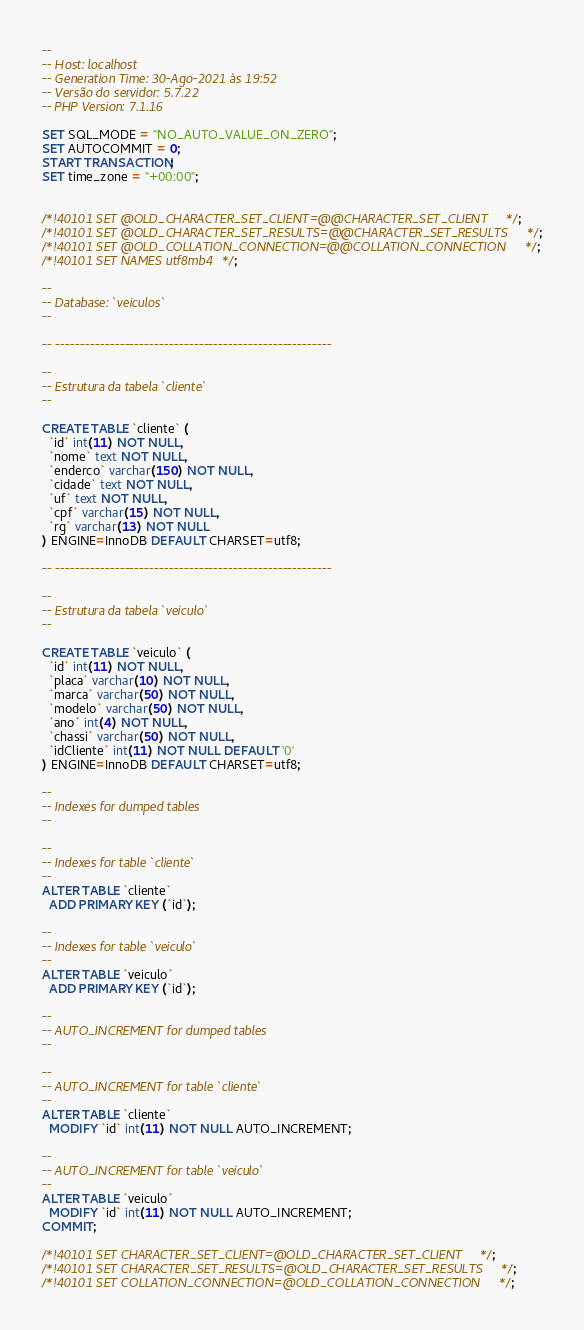Convert code to text. <code><loc_0><loc_0><loc_500><loc_500><_SQL_>--
-- Host: localhost
-- Generation Time: 30-Ago-2021 às 19:52
-- Versão do servidor: 5.7.22
-- PHP Version: 7.1.16

SET SQL_MODE = "NO_AUTO_VALUE_ON_ZERO";
SET AUTOCOMMIT = 0;
START TRANSACTION;
SET time_zone = "+00:00";


/*!40101 SET @OLD_CHARACTER_SET_CLIENT=@@CHARACTER_SET_CLIENT */;
/*!40101 SET @OLD_CHARACTER_SET_RESULTS=@@CHARACTER_SET_RESULTS */;
/*!40101 SET @OLD_COLLATION_CONNECTION=@@COLLATION_CONNECTION */;
/*!40101 SET NAMES utf8mb4 */;

--
-- Database: `veiculos`
--

-- --------------------------------------------------------

--
-- Estrutura da tabela `cliente`
--

CREATE TABLE `cliente` (
  `id` int(11) NOT NULL,
  `nome` text NOT NULL,
  `enderco` varchar(150) NOT NULL,
  `cidade` text NOT NULL,
  `uf` text NOT NULL,
  `cpf` varchar(15) NOT NULL,
  `rg` varchar(13) NOT NULL
) ENGINE=InnoDB DEFAULT CHARSET=utf8;

-- --------------------------------------------------------

--
-- Estrutura da tabela `veiculo`
--

CREATE TABLE `veiculo` (
  `id` int(11) NOT NULL,
  `placa` varchar(10) NOT NULL,
  `marca` varchar(50) NOT NULL,
  `modelo` varchar(50) NOT NULL,
  `ano` int(4) NOT NULL,
  `chassi` varchar(50) NOT NULL,
  `idCliente` int(11) NOT NULL DEFAULT '0'
) ENGINE=InnoDB DEFAULT CHARSET=utf8;

--
-- Indexes for dumped tables
--

--
-- Indexes for table `cliente`
--
ALTER TABLE `cliente`
  ADD PRIMARY KEY (`id`);

--
-- Indexes for table `veiculo`
--
ALTER TABLE `veiculo`
  ADD PRIMARY KEY (`id`);

--
-- AUTO_INCREMENT for dumped tables
--

--
-- AUTO_INCREMENT for table `cliente`
--
ALTER TABLE `cliente`
  MODIFY `id` int(11) NOT NULL AUTO_INCREMENT;

--
-- AUTO_INCREMENT for table `veiculo`
--
ALTER TABLE `veiculo`
  MODIFY `id` int(11) NOT NULL AUTO_INCREMENT;
COMMIT;

/*!40101 SET CHARACTER_SET_CLIENT=@OLD_CHARACTER_SET_CLIENT */;
/*!40101 SET CHARACTER_SET_RESULTS=@OLD_CHARACTER_SET_RESULTS */;
/*!40101 SET COLLATION_CONNECTION=@OLD_COLLATION_CONNECTION */;
</code> 